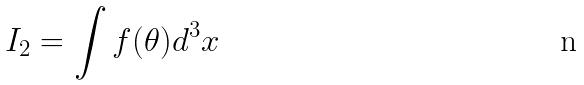<formula> <loc_0><loc_0><loc_500><loc_500>I _ { 2 } = \int f ( \theta ) d ^ { 3 } x</formula> 